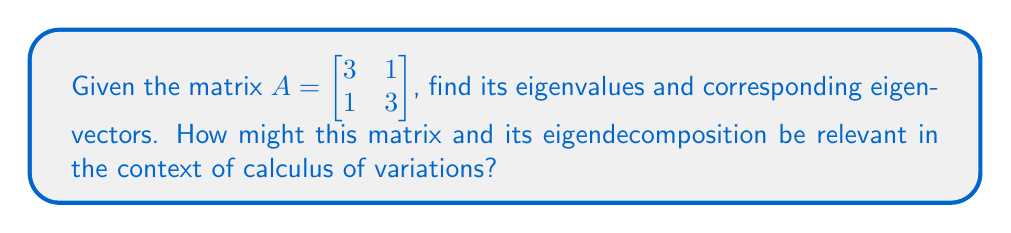Teach me how to tackle this problem. To find the eigenvalues and eigenvectors of matrix $A$, we follow these steps:

1) First, we find the eigenvalues by solving the characteristic equation:
   $det(A - \lambda I) = 0$

   $$\begin{vmatrix} 
   3-\lambda & 1 \\
   1 & 3-\lambda
   \end{vmatrix} = 0$$

   $(3-\lambda)^2 - 1 = 0$
   $\lambda^2 - 6\lambda + 8 = 0$

2) Solving this quadratic equation:
   $(\lambda - 4)(\lambda - 2) = 0$
   $\lambda_1 = 4$ and $\lambda_2 = 2$

3) For each eigenvalue, we find the corresponding eigenvector by solving $(A - \lambda I)v = 0$:

   For $\lambda_1 = 4$:
   $$\begin{bmatrix} 
   -1 & 1 \\
   1 & -1
   \end{bmatrix} \begin{bmatrix} 
   v_1 \\
   v_2
   \end{bmatrix} = \begin{bmatrix} 
   0 \\
   0
   \end{bmatrix}$$

   This gives us $v_1 = v_2$. We can choose $v_1 = \begin{bmatrix} 1 \\ 1 \end{bmatrix}$.

   For $\lambda_2 = 2$:
   $$\begin{bmatrix} 
   1 & 1 \\
   1 & 1
   \end{bmatrix} \begin{bmatrix} 
   v_1 \\
   v_2
   \end{bmatrix} = \begin{bmatrix} 
   0 \\
   0
   \end{bmatrix}$$

   This gives us $v_1 = -v_2$. We can choose $v_2 = \begin{bmatrix} 1 \\ -1 \end{bmatrix}$.

4) In the context of calculus of variations, eigendecomposition can be crucial in solving variational problems. The eigenvectors can represent the principal directions of variation in a functional space, while the eigenvalues can indicate the magnitude of this variation. This decomposition can simplify complex variational problems by allowing them to be expressed in terms of these principal components.
Answer: Eigenvalues: $\lambda_1 = 4$, $\lambda_2 = 2$
Eigenvectors: $v_1 = \begin{bmatrix} 1 \\ 1 \end{bmatrix}$, $v_2 = \begin{bmatrix} 1 \\ -1 \end{bmatrix}$ 